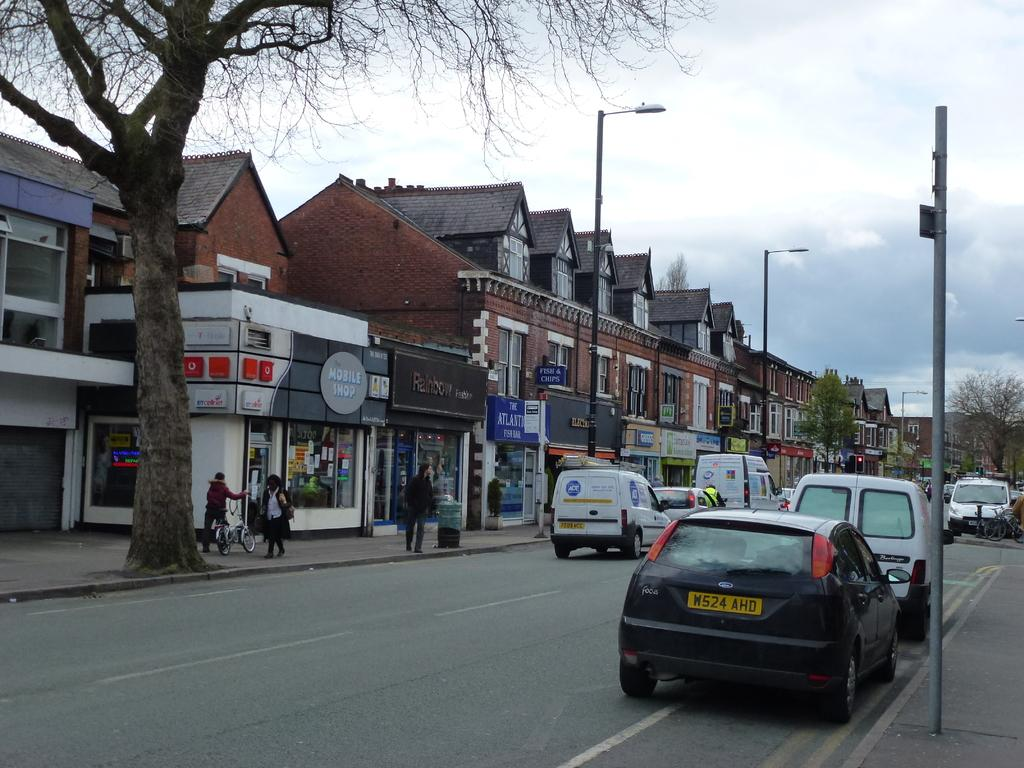What can be seen in the center of the image? There are cars on the road in the center of the image. What is visible in the background of the image? There are buildings, poles, trees, and persons in the background of the image. How would you describe the sky in the image? The sky is cloudy in the image. Where is the dock located in the image? There is no dock present in the image. What type of brush is being used by the committee in the image? There is no committee or brush present in the image. 